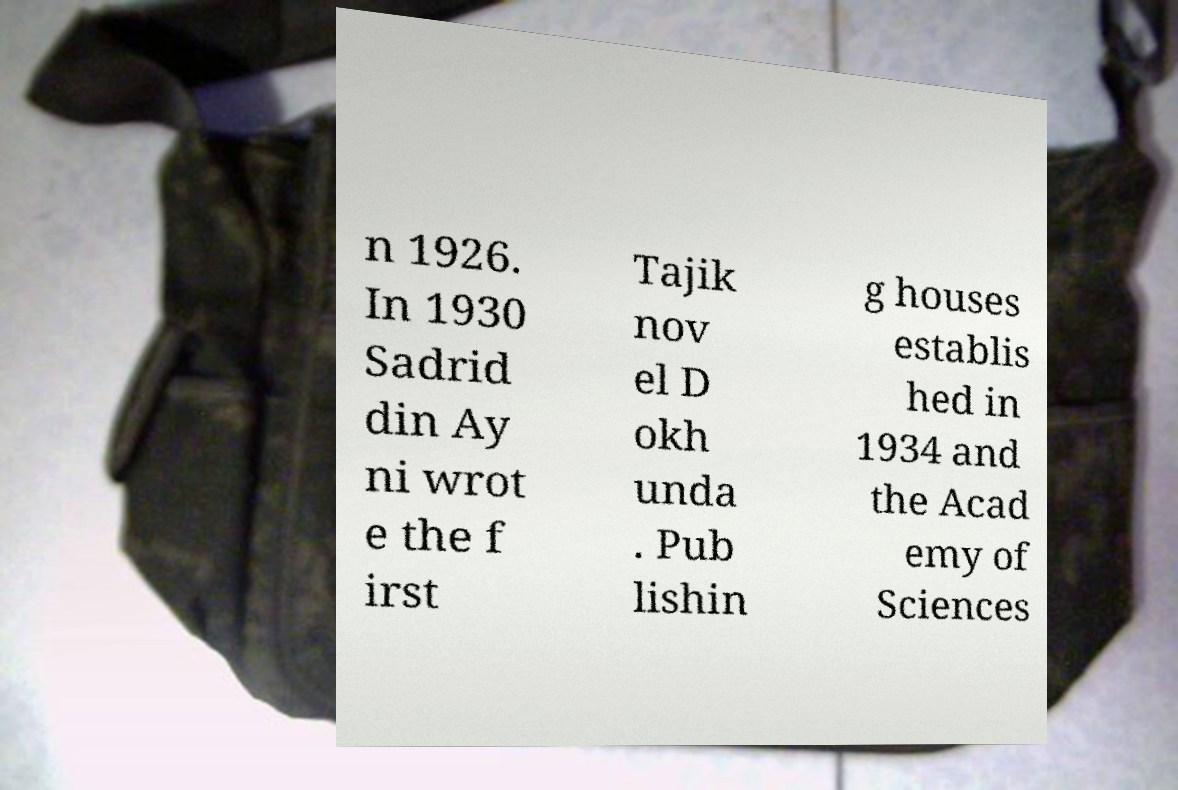There's text embedded in this image that I need extracted. Can you transcribe it verbatim? n 1926. In 1930 Sadrid din Ay ni wrot e the f irst Tajik nov el D okh unda . Pub lishin g houses establis hed in 1934 and the Acad emy of Sciences 